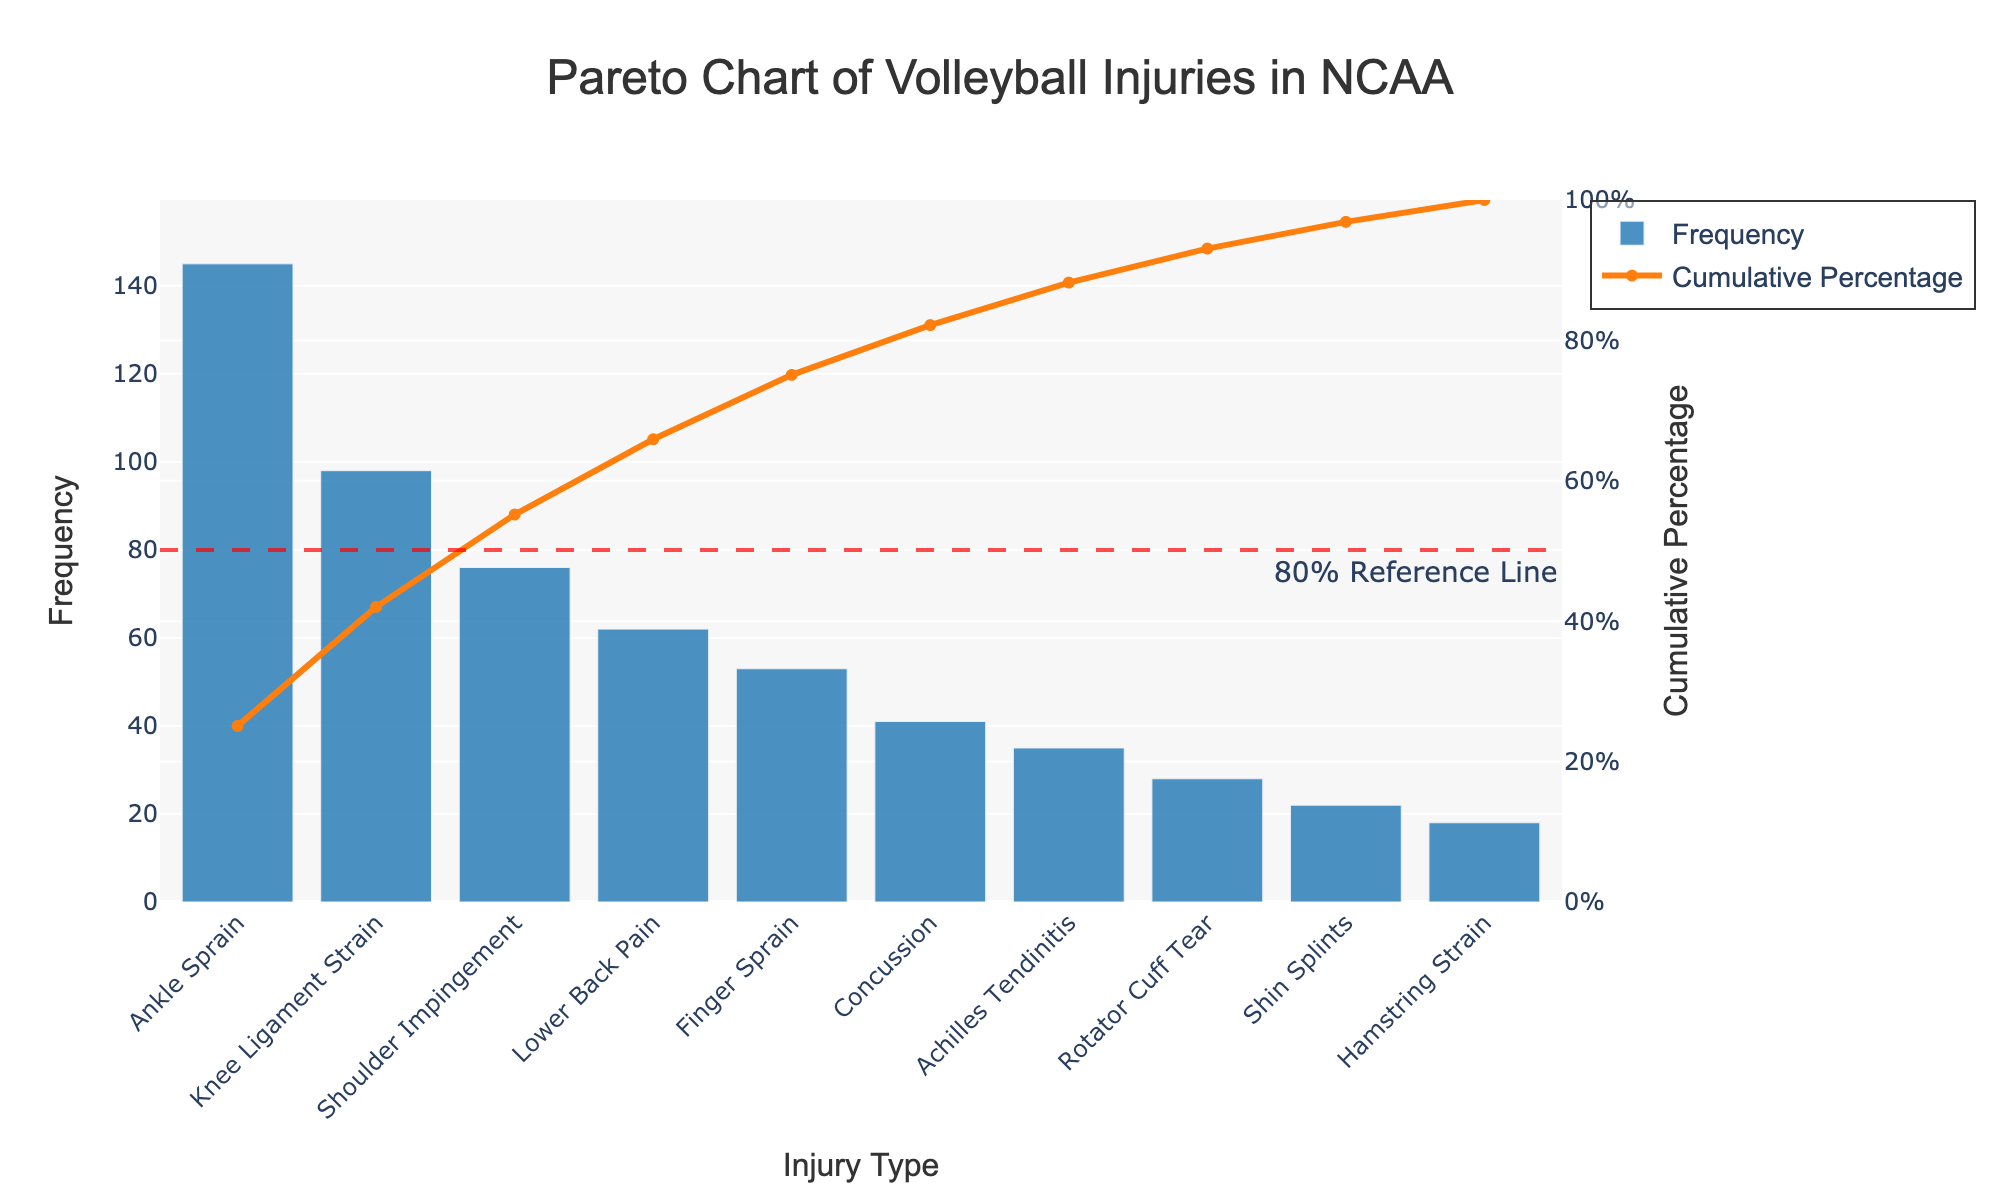What is the most common type of injury in NCAA volleyball according to the chart? The most common type of injury can be identified by looking at the highest bar in the bar chart. From the figure, the bar for "Ankle Sprain" is the highest, indicating it has the highest frequency.
Answer: Ankle Sprain What cumulative percentage do the top three injury types account for? To find this, we sum up the frequencies of the top three injury types and then look at their cumulative percentage from the chart. The first three bars are "Ankle Sprain", "Knee Ligament Strain", and "Shoulder Impingement" with frequencies 145, 98, and 76 respectively. Their cumulative sums yield 145 + 98 + 76 = 319, which in turn gives approximately 319 / 578 * 100, shown directly on the cumulative line chart.
Answer: Approximately 55% Which injury type is the first to cross the 80% cumulative percentage threshold? Look at the cumulative percentage line (orange) and identify the injury type right after it crosses the 80% reference line marked in red. Following the cumulative percentage line, we see "Concussion" is the first injury type to surpass the 80% threshold.
Answer: Concussion Are there any injury types that individually account for more than 20% of overall injuries? Check the height of each cumulative percentage bar against the 20% mark. "Ankle Sprain" with a cumulative percentage immediately shows more than 20%.
Answer: Yes, Ankle Sprain How many injury types compose the first 70% of the cumulative percentage? Follow the cumulative percentage line and count the number of injury types up to the point where it first crosses 70%. The count includes "Ankle Sprain", "Knee Ligament Strain", "Shoulder Impingement", "Lower Back Pain", and "Finger Sprain".
Answer: Five injury types Which injury type has the lowest frequency and what is it? Identify the shortest bar on the bar chart to see which injury has the lowest frequency. The bar for "Hamstring Strain" is the shortest.
Answer: Hamstring Strain How does the frequency of "Knee Ligament Strain" compare to that of "Finger Sprain"? Look at the heights of the bars for both "Knee Ligament Strain" and "Finger Sprain". "Knee Ligament Strain" is significantly taller than "Finger Sprain".
Answer: Knee Ligament Strain is higher What is the difference in frequency between "Shoulder Impingement" and "Achilles Tendinitis"? Subtract the frequency of "Achilles Tendinitis" from that of "Shoulder Impingement". The frequencies are 76 and 35 respectively, resulting in 76 - 35.
Answer: 41 Which three injury types have frequencies closest to the median frequency value? First determine the median frequency from the sorted data, which is the middle value (53 - Finger Sprain). Then find the three closest frequencies. Based on the list, these are "Finger Sprain", "Concussion", and "Achilles Tendinitis".
Answer: Finger Sprain, Concussion, Achilles Tendinitis 